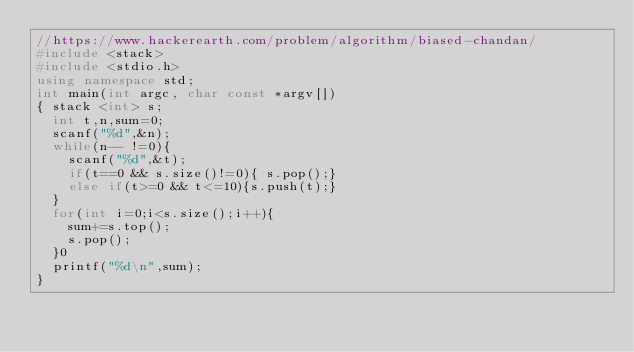Convert code to text. <code><loc_0><loc_0><loc_500><loc_500><_C++_>//https://www.hackerearth.com/problem/algorithm/biased-chandan/
#include <stack>
#include <stdio.h>
using namespace std;
int main(int argc, char const *argv[])
{	stack <int> s;
	int t,n,sum=0;
	scanf("%d",&n);
	while(n-- !=0){
		scanf("%d",&t);
		if(t==0 && s.size()!=0){ s.pop();}
		else if(t>=0 && t<=10){s.push(t);}
	}
	for(int i=0;i<s.size();i++){
		sum+=s.top();
		s.pop();
	}0
	printf("%d\n",sum);
}</code> 